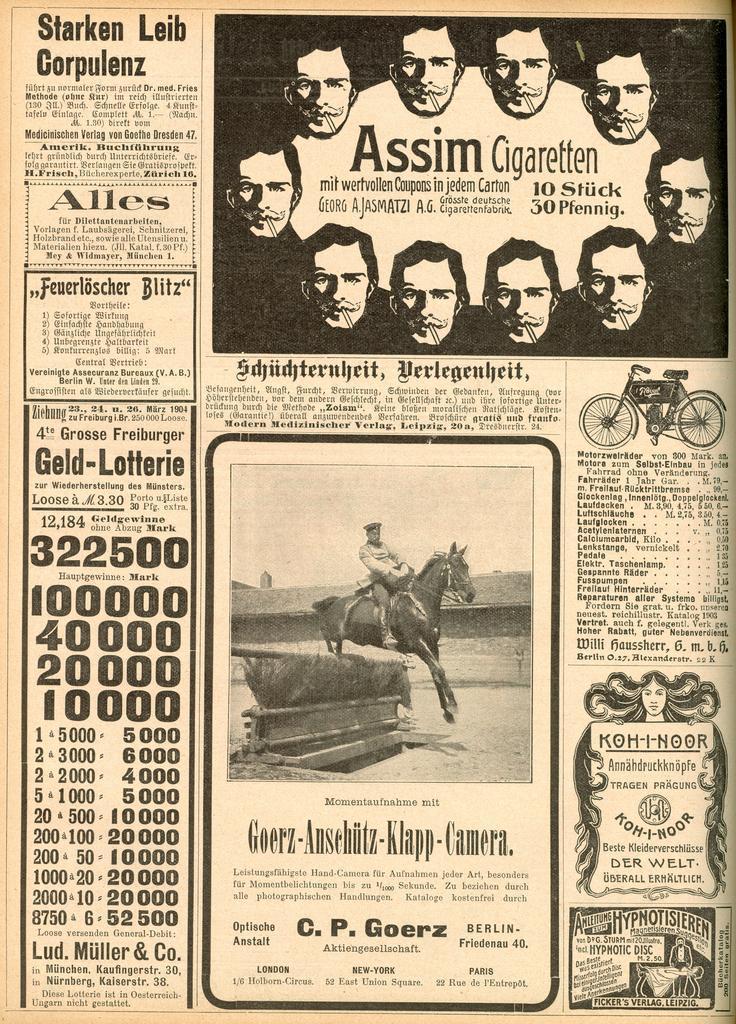How would you summarize this image in a sentence or two? In this picture we can see a paper, in the paper we can see some text, few people, horse and a bicycle. 